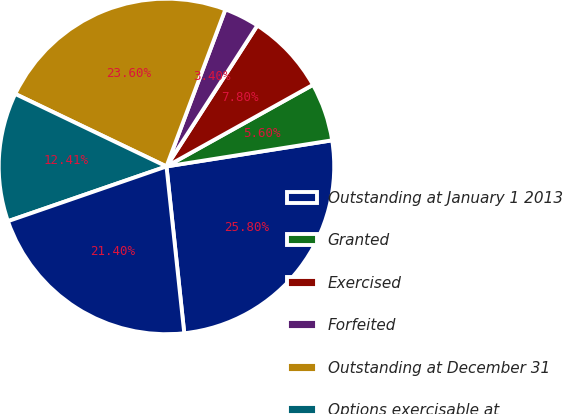<chart> <loc_0><loc_0><loc_500><loc_500><pie_chart><fcel>Outstanding at January 1 2013<fcel>Granted<fcel>Exercised<fcel>Forfeited<fcel>Outstanding at December 31<fcel>Options exercisable at<fcel>Vested and non-vested expected<nl><fcel>25.8%<fcel>5.6%<fcel>7.8%<fcel>3.4%<fcel>23.6%<fcel>12.41%<fcel>21.4%<nl></chart> 